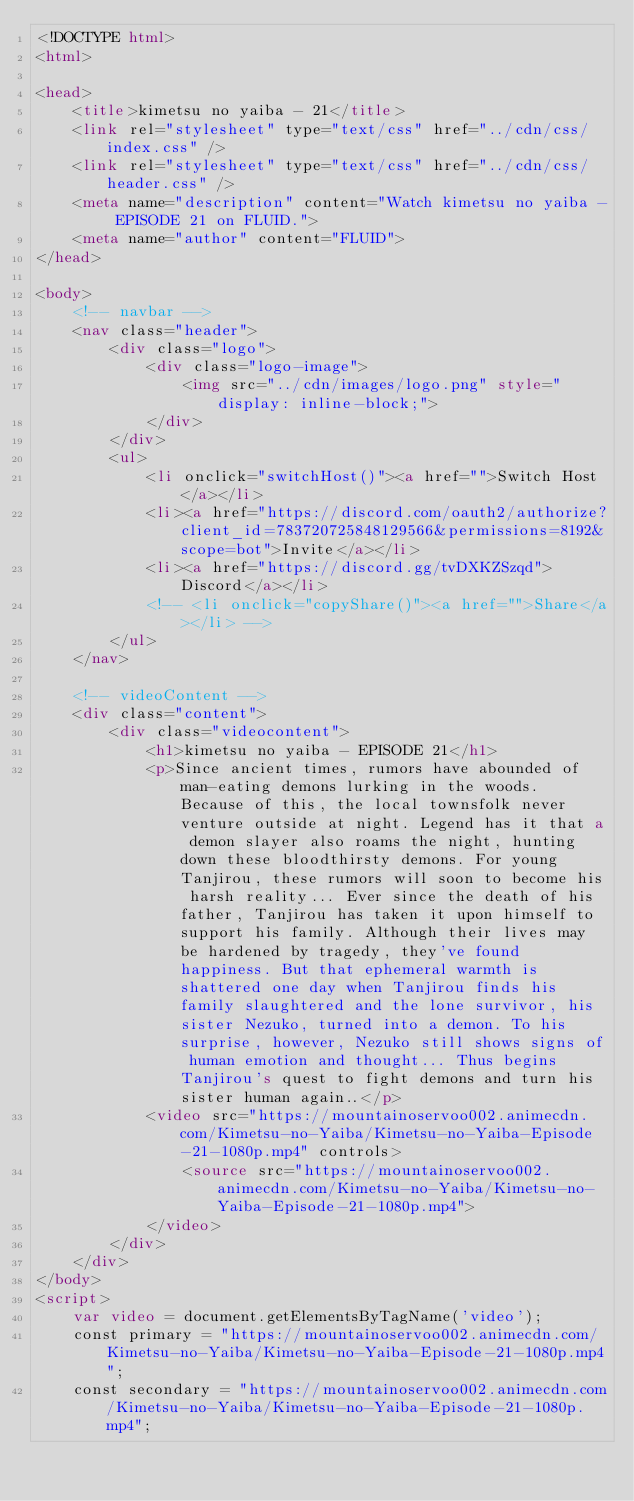<code> <loc_0><loc_0><loc_500><loc_500><_HTML_><!DOCTYPE html>
<html>

<head>
    <title>kimetsu no yaiba - 21</title>
    <link rel="stylesheet" type="text/css" href="../cdn/css/index.css" />
    <link rel="stylesheet" type="text/css" href="../cdn/css/header.css" />
    <meta name="description" content="Watch kimetsu no yaiba - EPISODE 21 on FLUID.">
    <meta name="author" content="FLUID">
</head>

<body>
    <!-- navbar -->
    <nav class="header">
        <div class="logo">
            <div class="logo-image">
                <img src="../cdn/images/logo.png" style="display: inline-block;">
            </div>
        </div>
        <ul>
            <li onclick="switchHost()"><a href="">Switch Host</a></li>
            <li><a href="https://discord.com/oauth2/authorize?client_id=783720725848129566&permissions=8192&scope=bot">Invite</a></li>
            <li><a href="https://discord.gg/tvDXKZSzqd">Discord</a></li>
            <!-- <li onclick="copyShare()"><a href="">Share</a></li> -->
        </ul>
    </nav>

    <!-- videoContent -->
    <div class="content">
        <div class="videocontent">
            <h1>kimetsu no yaiba - EPISODE 21</h1>
            <p>Since ancient times, rumors have abounded of man-eating demons lurking in the woods. Because of this, the local townsfolk never venture outside at night. Legend has it that a demon slayer also roams the night, hunting down these bloodthirsty demons. For young Tanjirou, these rumors will soon to become his harsh reality... Ever since the death of his father, Tanjirou has taken it upon himself to support his family. Although their lives may be hardened by tragedy, they've found happiness. But that ephemeral warmth is shattered one day when Tanjirou finds his family slaughtered and the lone survivor, his sister Nezuko, turned into a demon. To his surprise, however, Nezuko still shows signs of human emotion and thought... Thus begins Tanjirou's quest to fight demons and turn his sister human again..</p>
            <video src="https://mountainoservoo002.animecdn.com/Kimetsu-no-Yaiba/Kimetsu-no-Yaiba-Episode-21-1080p.mp4" controls>
                <source src="https://mountainoservoo002.animecdn.com/Kimetsu-no-Yaiba/Kimetsu-no-Yaiba-Episode-21-1080p.mp4">
            </video>
        </div>
    </div>
</body>
<script>
    var video = document.getElementsByTagName('video');
    const primary = "https://mountainoservoo002.animecdn.com/Kimetsu-no-Yaiba/Kimetsu-no-Yaiba-Episode-21-1080p.mp4";
    const secondary = "https://mountainoservoo002.animecdn.com/Kimetsu-no-Yaiba/Kimetsu-no-Yaiba-Episode-21-1080p.mp4";</code> 